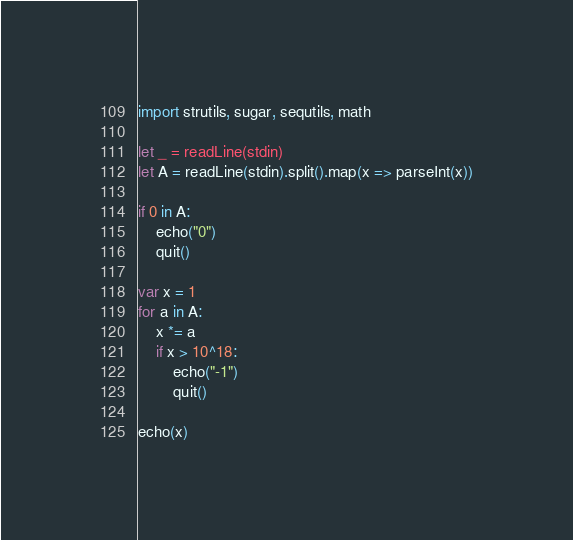Convert code to text. <code><loc_0><loc_0><loc_500><loc_500><_Nim_>import strutils, sugar, sequtils, math

let _ = readLine(stdin)
let A = readLine(stdin).split().map(x => parseInt(x))

if 0 in A:
    echo("0")
    quit()

var x = 1
for a in A:
    x *= a
    if x > 10^18:
        echo("-1")
        quit() 

echo(x)</code> 